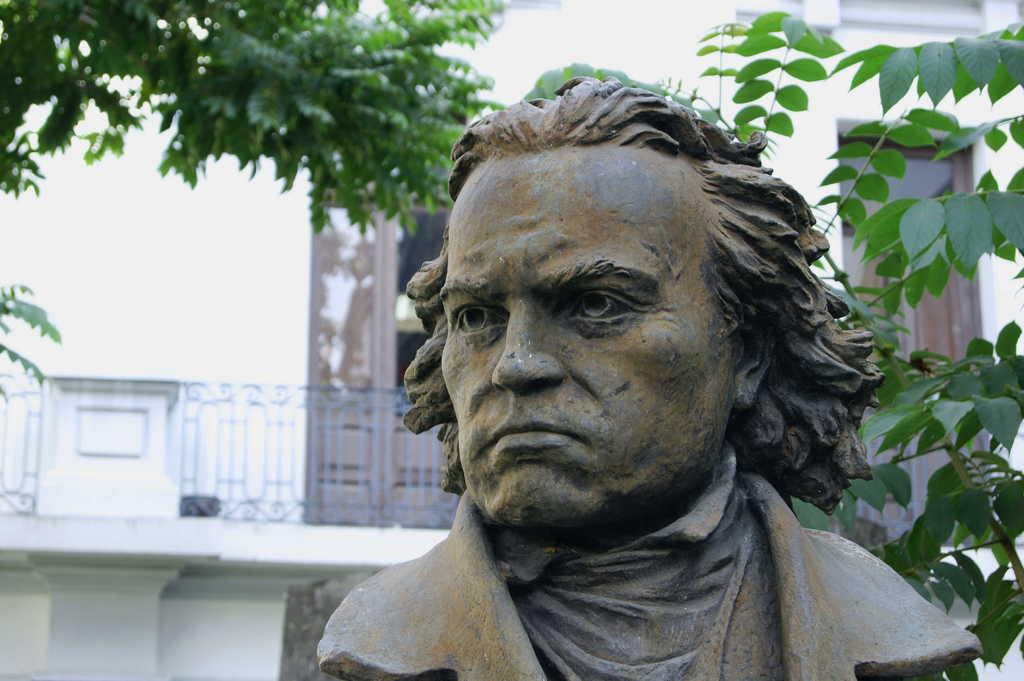What is the main subject of the image? There is a statue of a man in the image. What can be seen in the background of the image? There is a building in the background of the image. What type of natural elements are visible in the image? There are trees visible in the image. What floor is the statue located on in the image? The image does not provide information about the floor, as it is a statue and not located inside a building. 